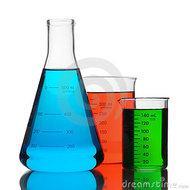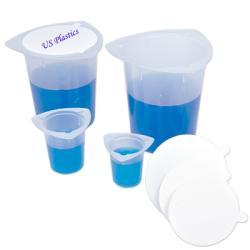The first image is the image on the left, the second image is the image on the right. Analyze the images presented: Is the assertion "One image shows beakers filled with at least three different colors of liquid." valid? Answer yes or no. Yes. 